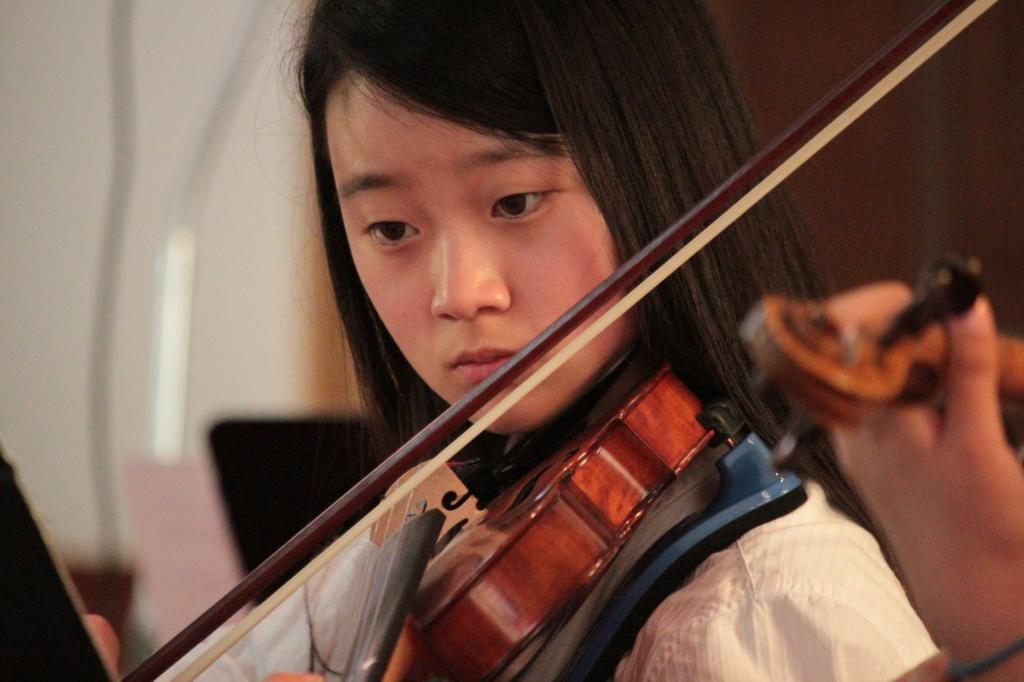In one or two sentences, can you explain what this image depicts? This picture shows a girl playing a violin. 